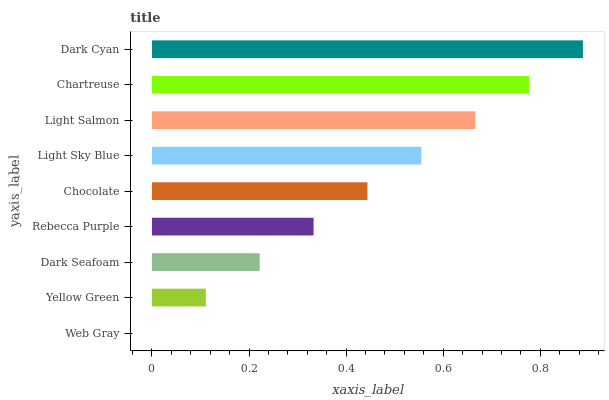Is Web Gray the minimum?
Answer yes or no. Yes. Is Dark Cyan the maximum?
Answer yes or no. Yes. Is Yellow Green the minimum?
Answer yes or no. No. Is Yellow Green the maximum?
Answer yes or no. No. Is Yellow Green greater than Web Gray?
Answer yes or no. Yes. Is Web Gray less than Yellow Green?
Answer yes or no. Yes. Is Web Gray greater than Yellow Green?
Answer yes or no. No. Is Yellow Green less than Web Gray?
Answer yes or no. No. Is Chocolate the high median?
Answer yes or no. Yes. Is Chocolate the low median?
Answer yes or no. Yes. Is Light Sky Blue the high median?
Answer yes or no. No. Is Dark Seafoam the low median?
Answer yes or no. No. 